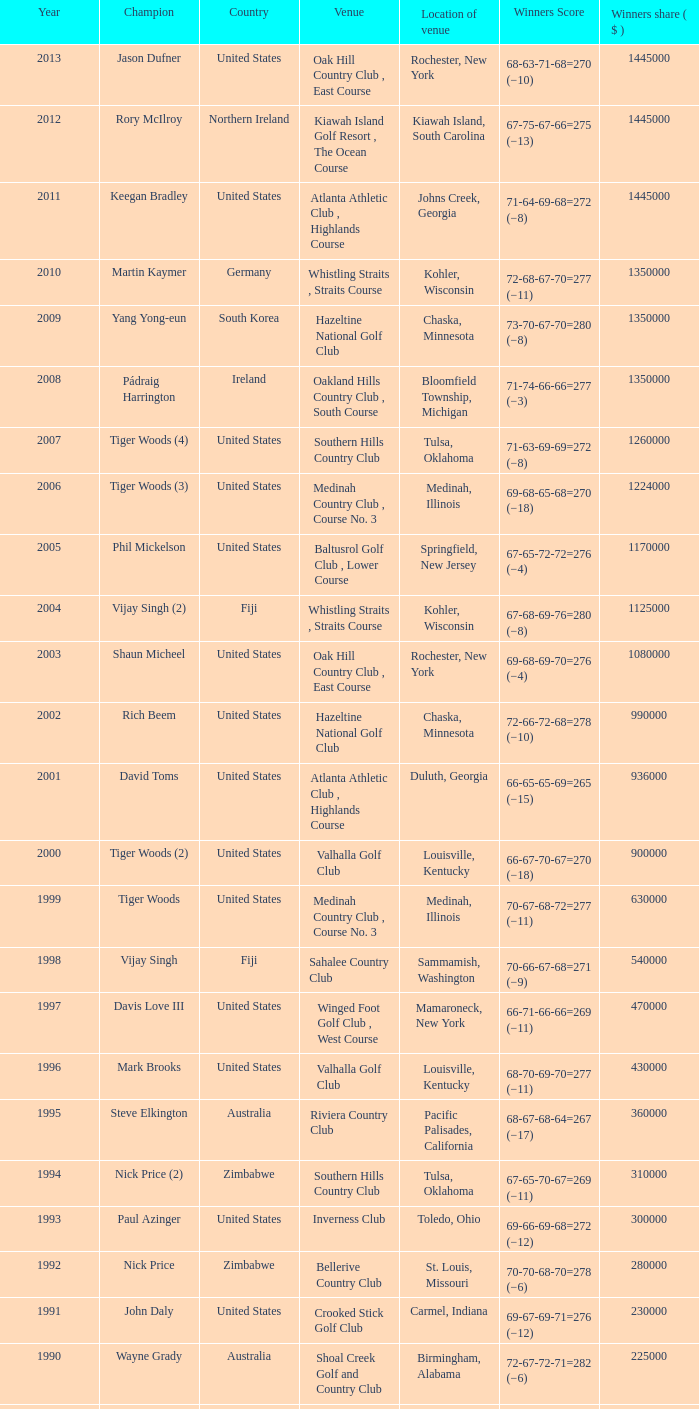Where is the Bellerive Country Club venue located? St. Louis, Missouri. 